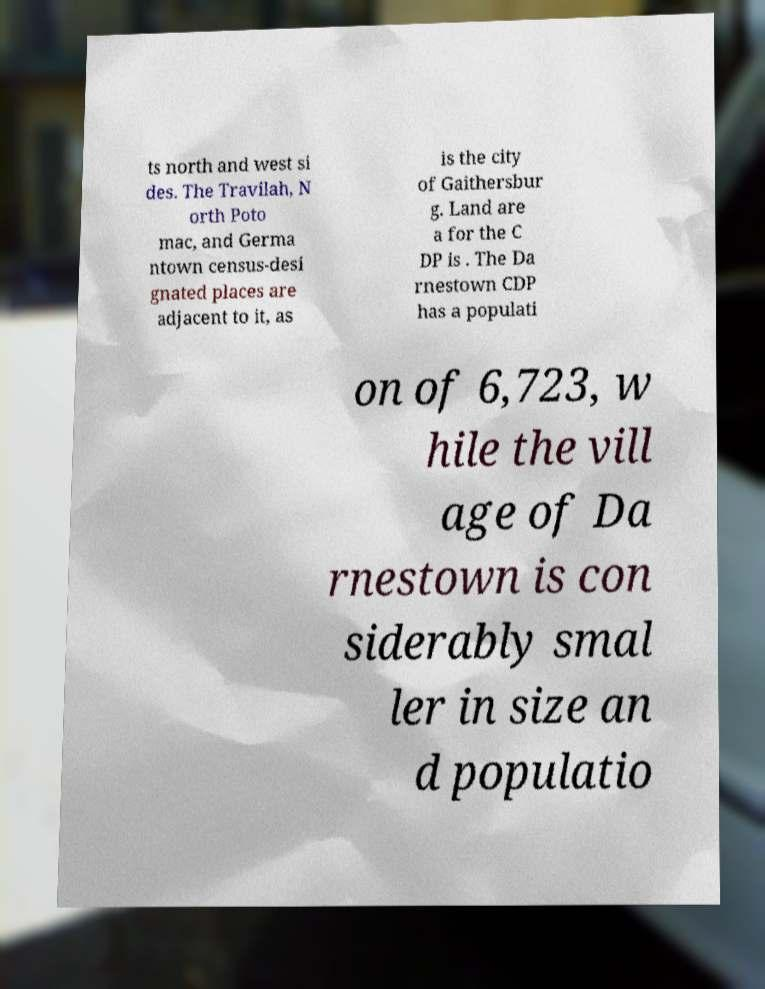Can you accurately transcribe the text from the provided image for me? ts north and west si des. The Travilah, N orth Poto mac, and Germa ntown census-desi gnated places are adjacent to it, as is the city of Gaithersbur g. Land are a for the C DP is . The Da rnestown CDP has a populati on of 6,723, w hile the vill age of Da rnestown is con siderably smal ler in size an d populatio 